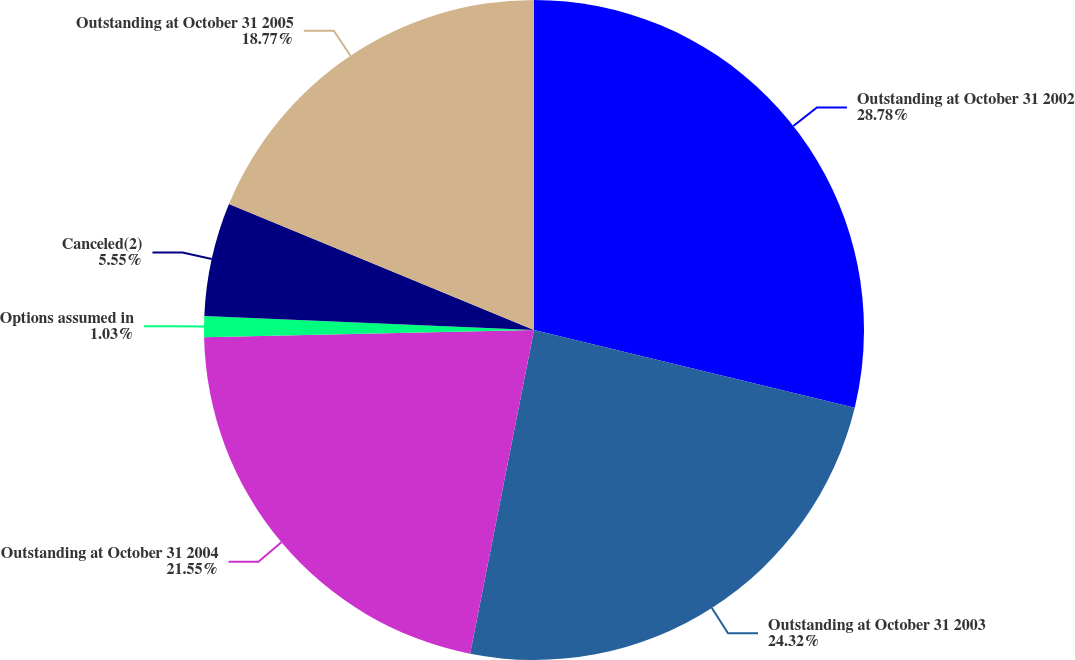Convert chart. <chart><loc_0><loc_0><loc_500><loc_500><pie_chart><fcel>Outstanding at October 31 2002<fcel>Outstanding at October 31 2003<fcel>Outstanding at October 31 2004<fcel>Options assumed in<fcel>Canceled(2)<fcel>Outstanding at October 31 2005<nl><fcel>28.78%<fcel>24.32%<fcel>21.55%<fcel>1.03%<fcel>5.55%<fcel>18.77%<nl></chart> 